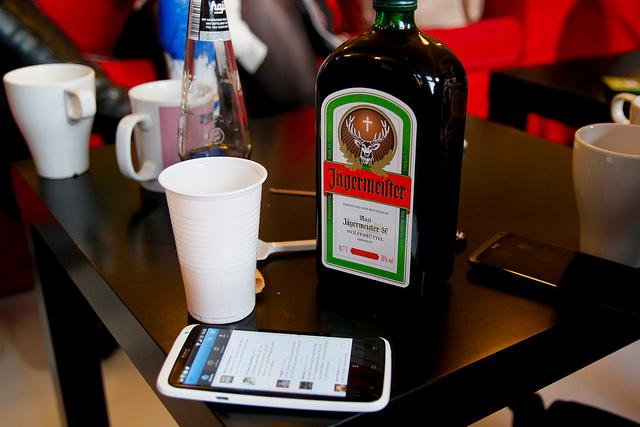What athlete has a last name that is similar to the name on the bottle?

Choices:
A) otis nixon
B) mike richter
C) jaromir jagr
D) ben hogan jaromir jagr 